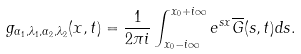Convert formula to latex. <formula><loc_0><loc_0><loc_500><loc_500>g _ { \alpha _ { 1 } , \lambda _ { 1 } , \alpha _ { 2 } , \lambda _ { 2 } } ( x , t ) = \frac { 1 } { 2 \pi i } \int _ { x _ { 0 } - i \infty } ^ { x _ { 0 } + i \infty } e ^ { s x } \overline { G } ( s , t ) d s . \\</formula> 